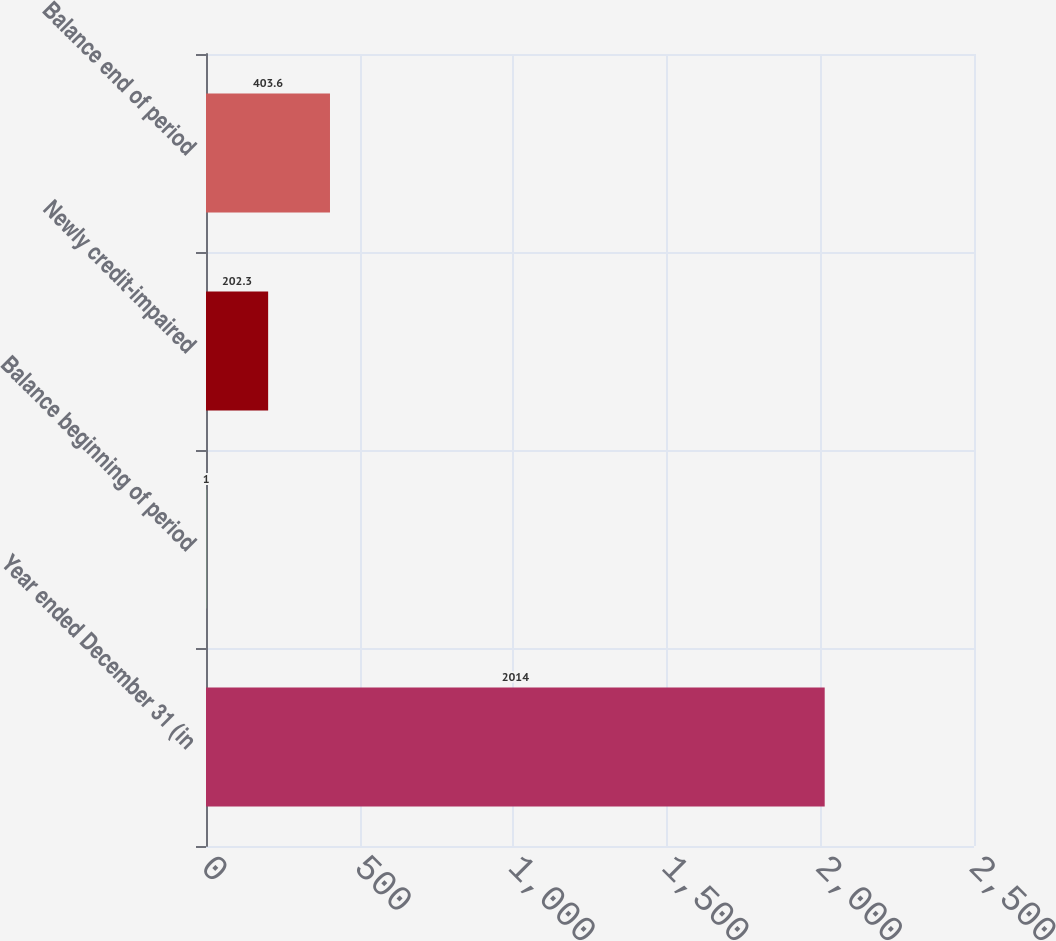Convert chart to OTSL. <chart><loc_0><loc_0><loc_500><loc_500><bar_chart><fcel>Year ended December 31 (in<fcel>Balance beginning of period<fcel>Newly credit-impaired<fcel>Balance end of period<nl><fcel>2014<fcel>1<fcel>202.3<fcel>403.6<nl></chart> 